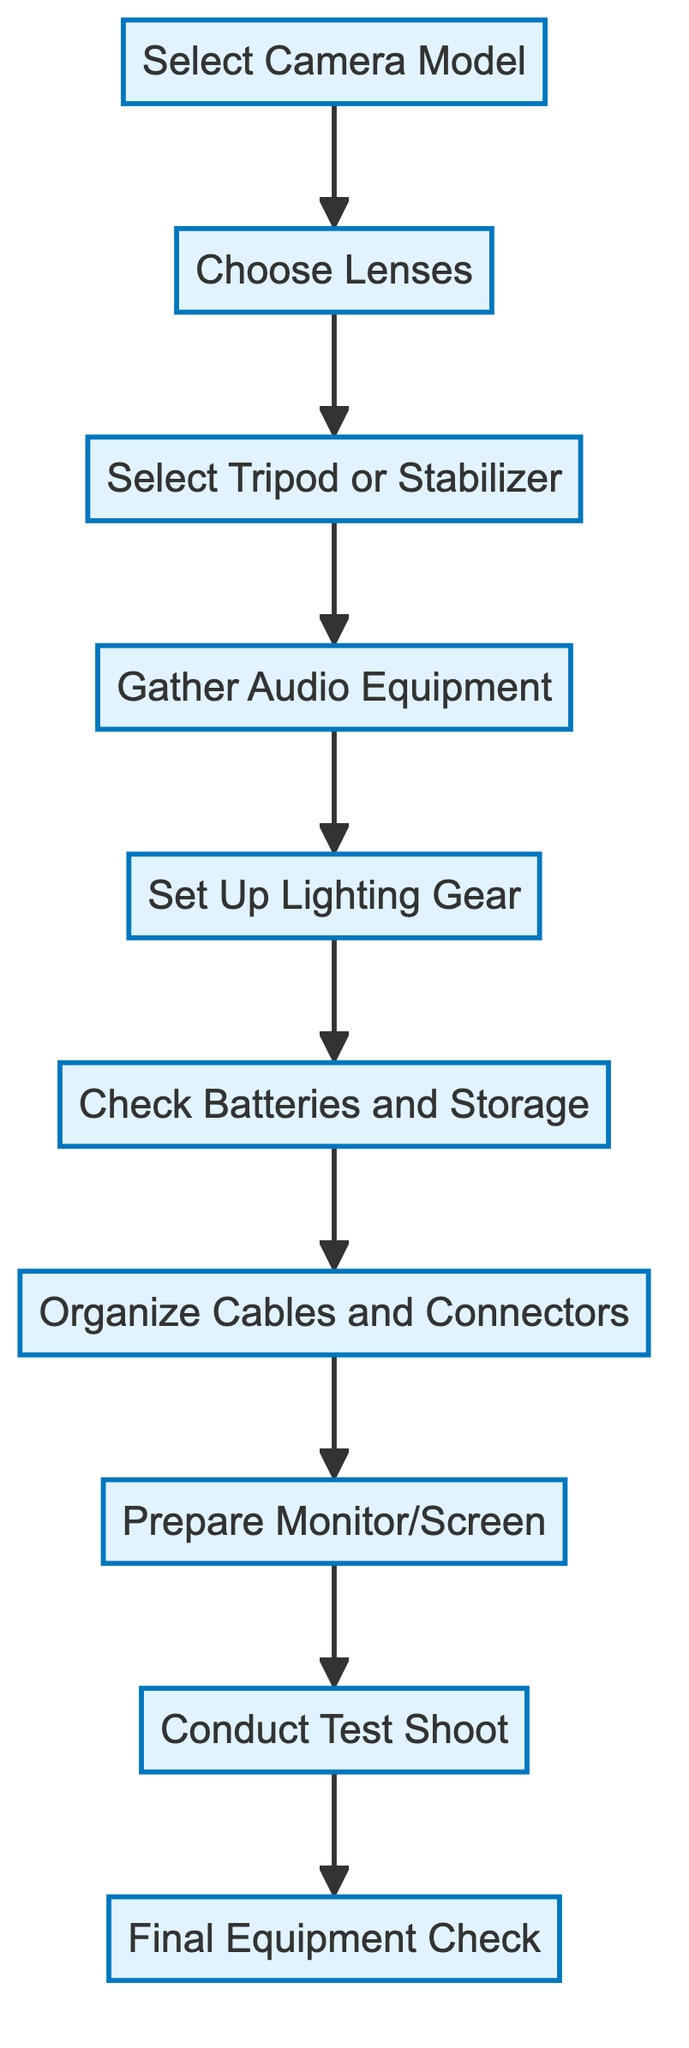What is the first step in the equipment setup process? The first step is indicated by the starting point of the flowchart, which leads to selecting the camera model.
Answer: Select Camera Model How many total steps are shown in the diagram? Counting all process elements in the diagram, there are ten steps listed from selecting the camera model to the final equipment check.
Answer: Ten Which equipment should be prepared after organizing cables and connectors? Following the organization of cables, the next step in the flow direction is to prepare the monitor/screen.
Answer: Prepare Monitor/Screen What is the last action to be taken before starting the film shoot? According to the flow structure, the last action before proceeding to a shoot is conducting a final equipment check.
Answer: Final Equipment Check What node follows the selection of lenses? The flowchart indicates that after choosing lenses, the next step is to select a tripod or stabilizer.
Answer: Select Tripod or Stabilizer What is the relationship between audio equipment and lighting in the diagram? The diagram shows that audio equipment gathering is directly connected to setting up lighting gear, meaning audio equipment must be prepared first before proceeding to lighting.
Answer: Audio equipment must be gathered before lighting What happens after the test shoot is conducted? Upon completing a test shoot, the final step in the process is conducting a final equipment check, indicating a review of all equipment before the shooting begins.
Answer: Final Equipment Check Is checking batteries and storage before organizing cables? Yes, the flowchart clearly shows that checking batteries and storage occurs prior to organizing cables and connectors, following a sequential path in the diagram.
Answer: Yes What is highlighted as the first and last steps in the diagram? The first step is 'Select Camera Model' and the last step is 'Final Equipment Check', which indicates the starting and concluding activities, respectively.
Answer: Select Camera Model and Final Equipment Check 